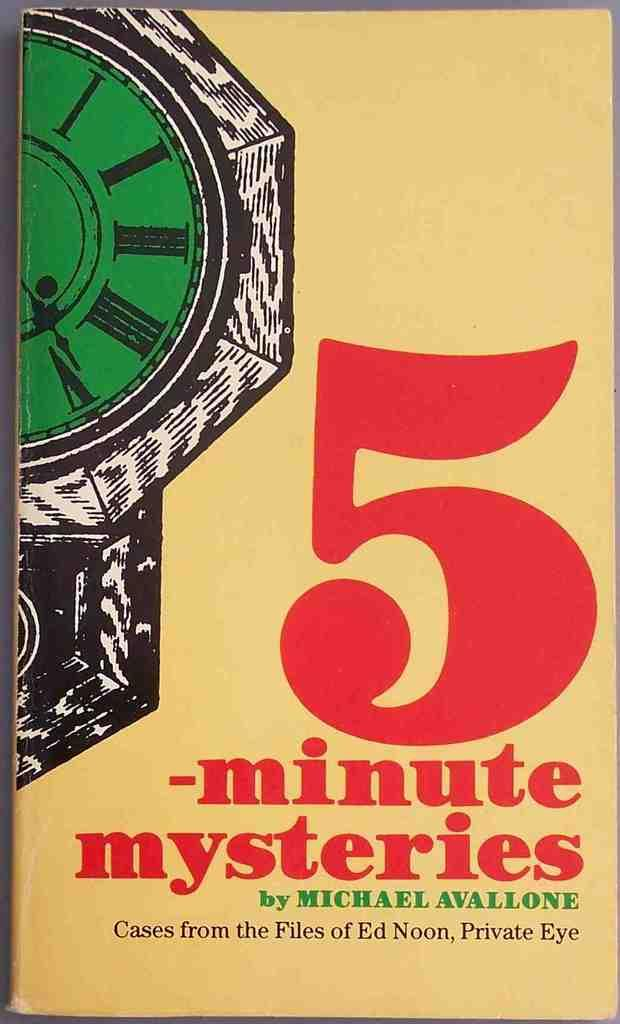<image>
Describe the image concisely. a book that is called 5 minute mysteries 